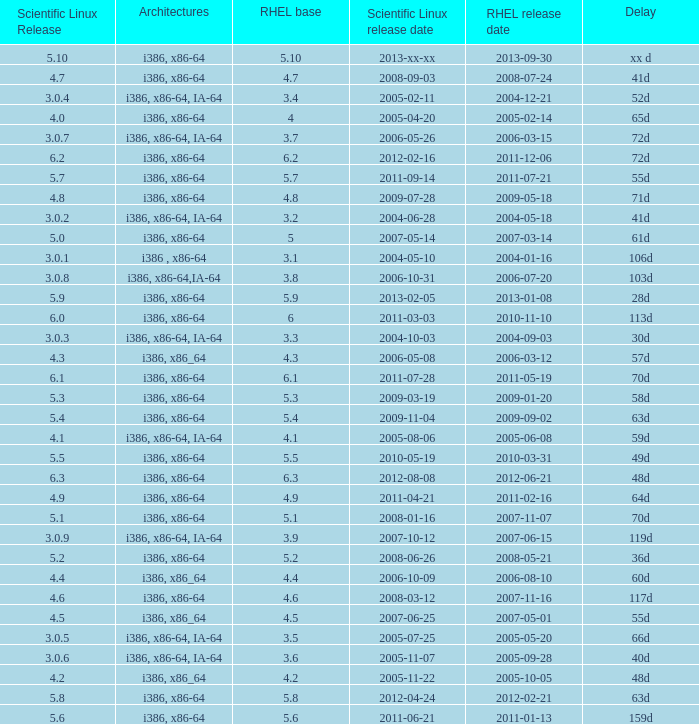Name the delay when scientific linux release is 5.10 Xx d. 